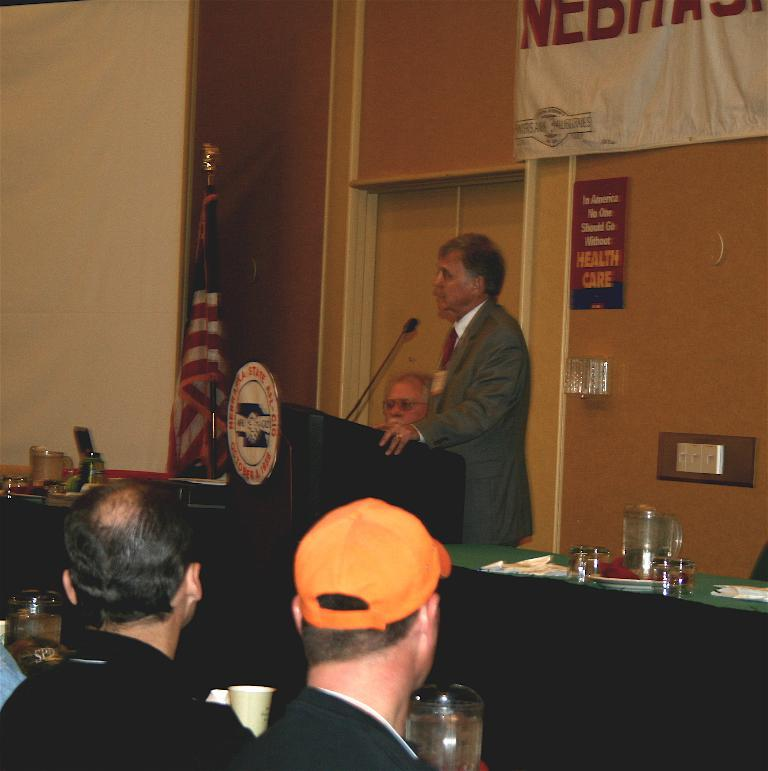What is the man in the image doing? The man is talking into a microphone. How many people are visible at the bottom of the image? There are many people at the bottom of the image. What can be seen in the background of the image? There is a wall and a door in the background of the image. What type of orange is being used as a prop in the image? There is no orange present in the image. 